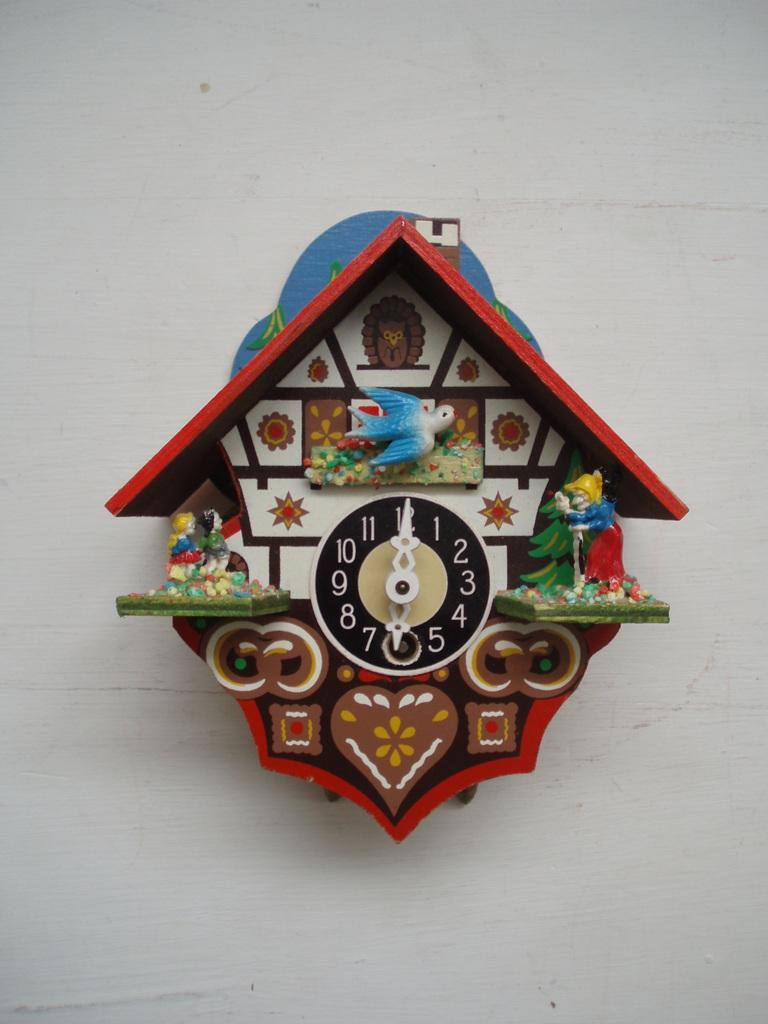What object is present in the image that displays time? There is a clock in the image. Where is the clock located? The clock is attached to a wall. What color is the wall that the clock is attached to? The wall is white. What type of spoon is used to stir the value in the image? There is no spoon or value present in the image; it only features a clock attached to a white wall. 